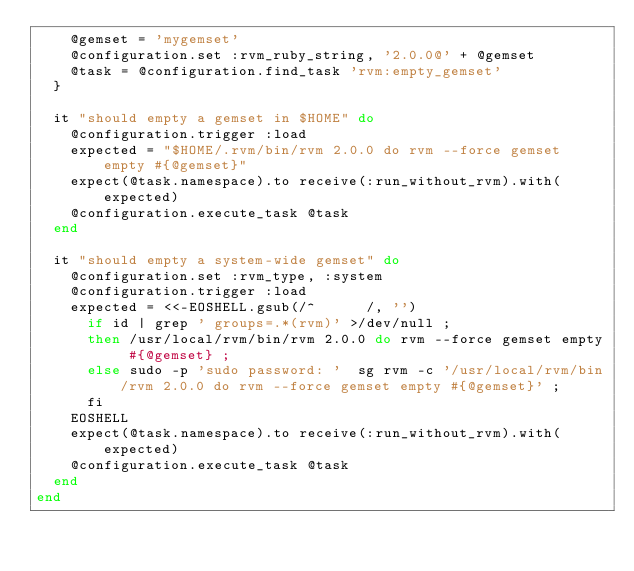<code> <loc_0><loc_0><loc_500><loc_500><_Ruby_>    @gemset = 'mygemset'
    @configuration.set :rvm_ruby_string, '2.0.0@' + @gemset
    @task = @configuration.find_task 'rvm:empty_gemset'
  }

  it "should empty a gemset in $HOME" do
    @configuration.trigger :load
    expected = "$HOME/.rvm/bin/rvm 2.0.0 do rvm --force gemset empty #{@gemset}"
    expect(@task.namespace).to receive(:run_without_rvm).with(expected)
    @configuration.execute_task @task
  end

  it "should empty a system-wide gemset" do
    @configuration.set :rvm_type, :system
    @configuration.trigger :load
    expected = <<-EOSHELL.gsub(/^      /, '')
      if id | grep ' groups=.*(rvm)' >/dev/null ;
      then /usr/local/rvm/bin/rvm 2.0.0 do rvm --force gemset empty #{@gemset} ;
      else sudo -p 'sudo password: '  sg rvm -c '/usr/local/rvm/bin/rvm 2.0.0 do rvm --force gemset empty #{@gemset}' ;
      fi
    EOSHELL
    expect(@task.namespace).to receive(:run_without_rvm).with(expected)
    @configuration.execute_task @task
  end
end
</code> 